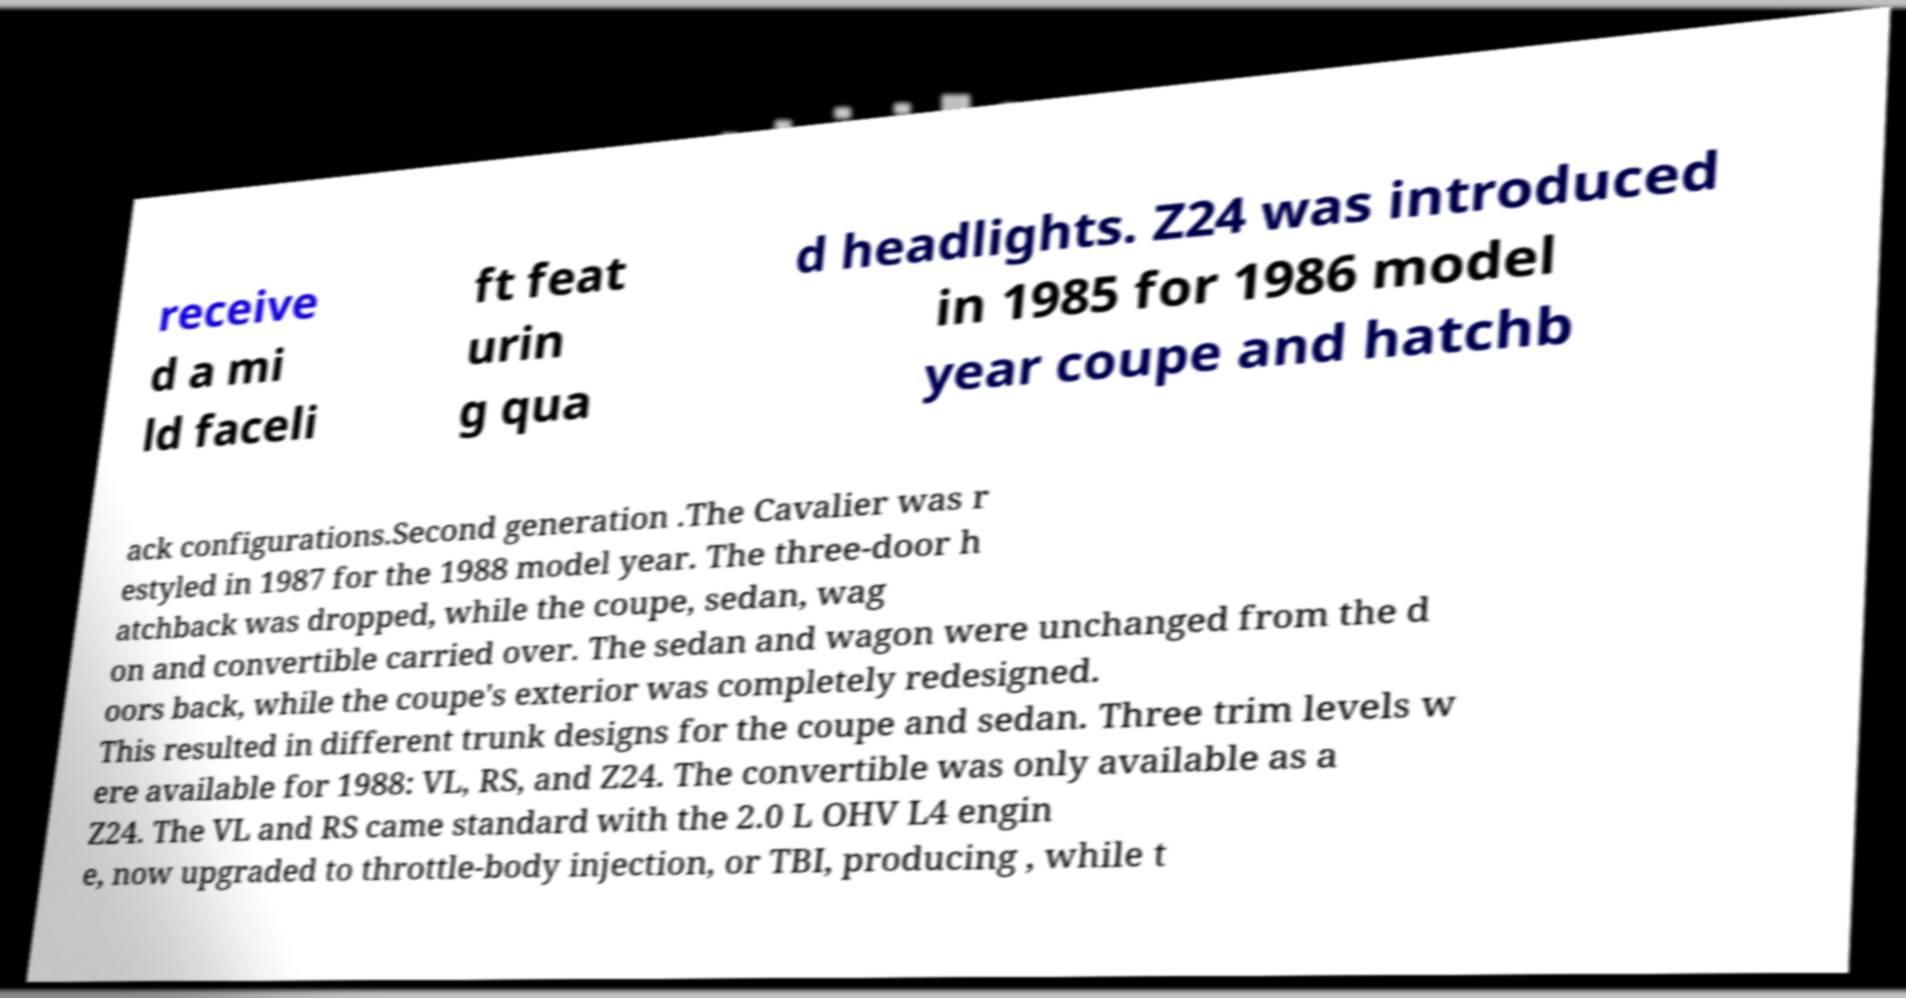Please identify and transcribe the text found in this image. receive d a mi ld faceli ft feat urin g qua d headlights. Z24 was introduced in 1985 for 1986 model year coupe and hatchb ack configurations.Second generation .The Cavalier was r estyled in 1987 for the 1988 model year. The three-door h atchback was dropped, while the coupe, sedan, wag on and convertible carried over. The sedan and wagon were unchanged from the d oors back, while the coupe's exterior was completely redesigned. This resulted in different trunk designs for the coupe and sedan. Three trim levels w ere available for 1988: VL, RS, and Z24. The convertible was only available as a Z24. The VL and RS came standard with the 2.0 L OHV L4 engin e, now upgraded to throttle-body injection, or TBI, producing , while t 